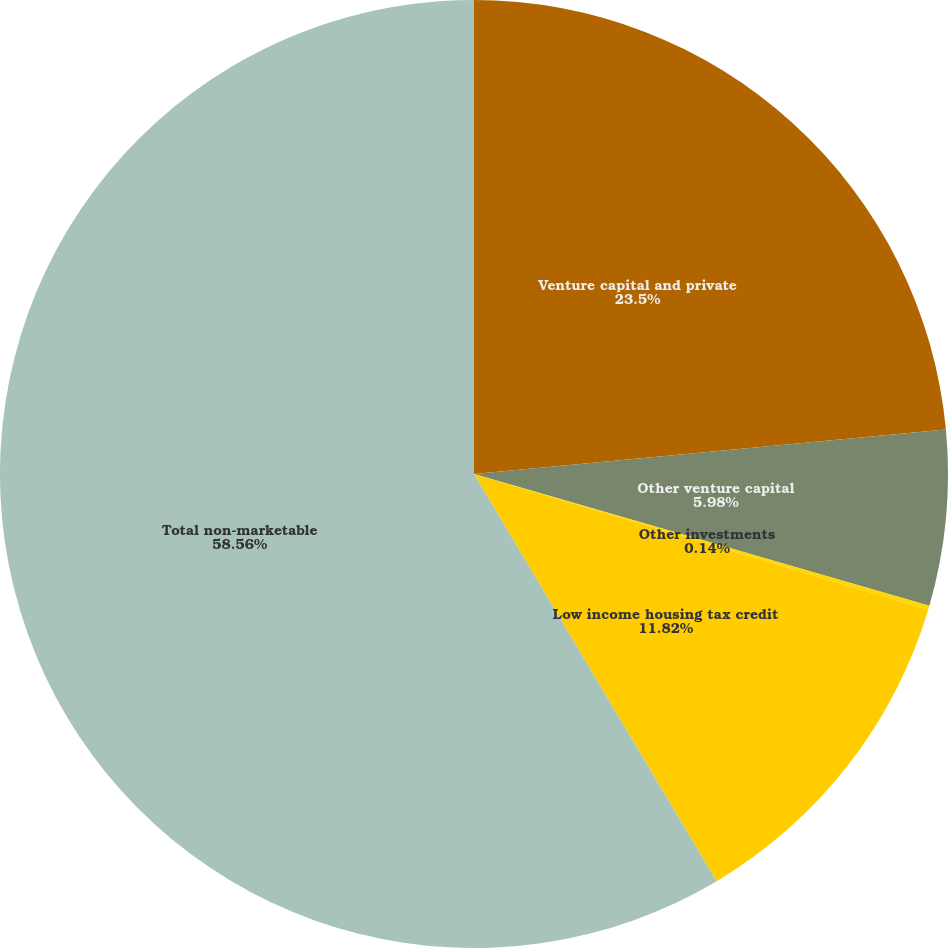<chart> <loc_0><loc_0><loc_500><loc_500><pie_chart><fcel>Venture capital and private<fcel>Other venture capital<fcel>Other investments<fcel>Low income housing tax credit<fcel>Total non-marketable<nl><fcel>23.5%<fcel>5.98%<fcel>0.14%<fcel>11.82%<fcel>58.55%<nl></chart> 